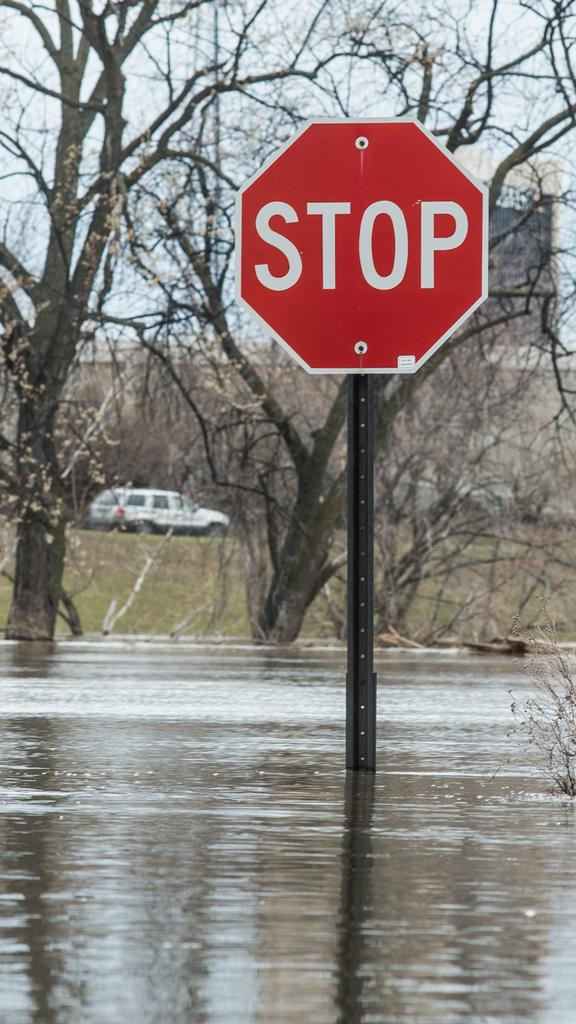What is the main object in the middle of the image? There is a stop sign in the middle of the image. What can be seen in the background of the image? There are trees, a building, and a car in the background of the image. What is the condition of the ground in the image? There is water on the ground in the image. How many toys can be seen hanging from the cobweb in the image? There are no toys or cobwebs present in the image. 